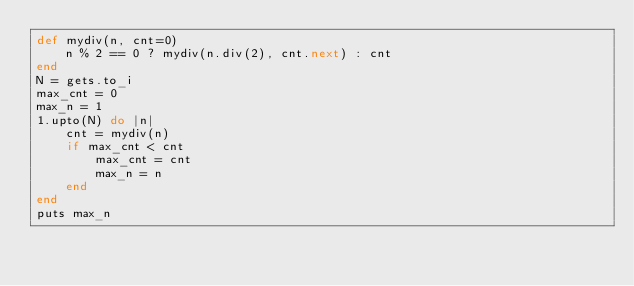<code> <loc_0><loc_0><loc_500><loc_500><_Ruby_>def mydiv(n, cnt=0)
    n % 2 == 0 ? mydiv(n.div(2), cnt.next) : cnt
end
N = gets.to_i
max_cnt = 0
max_n = 1
1.upto(N) do |n|
    cnt = mydiv(n)
    if max_cnt < cnt
        max_cnt = cnt 
        max_n = n
    end
end
puts max_n</code> 